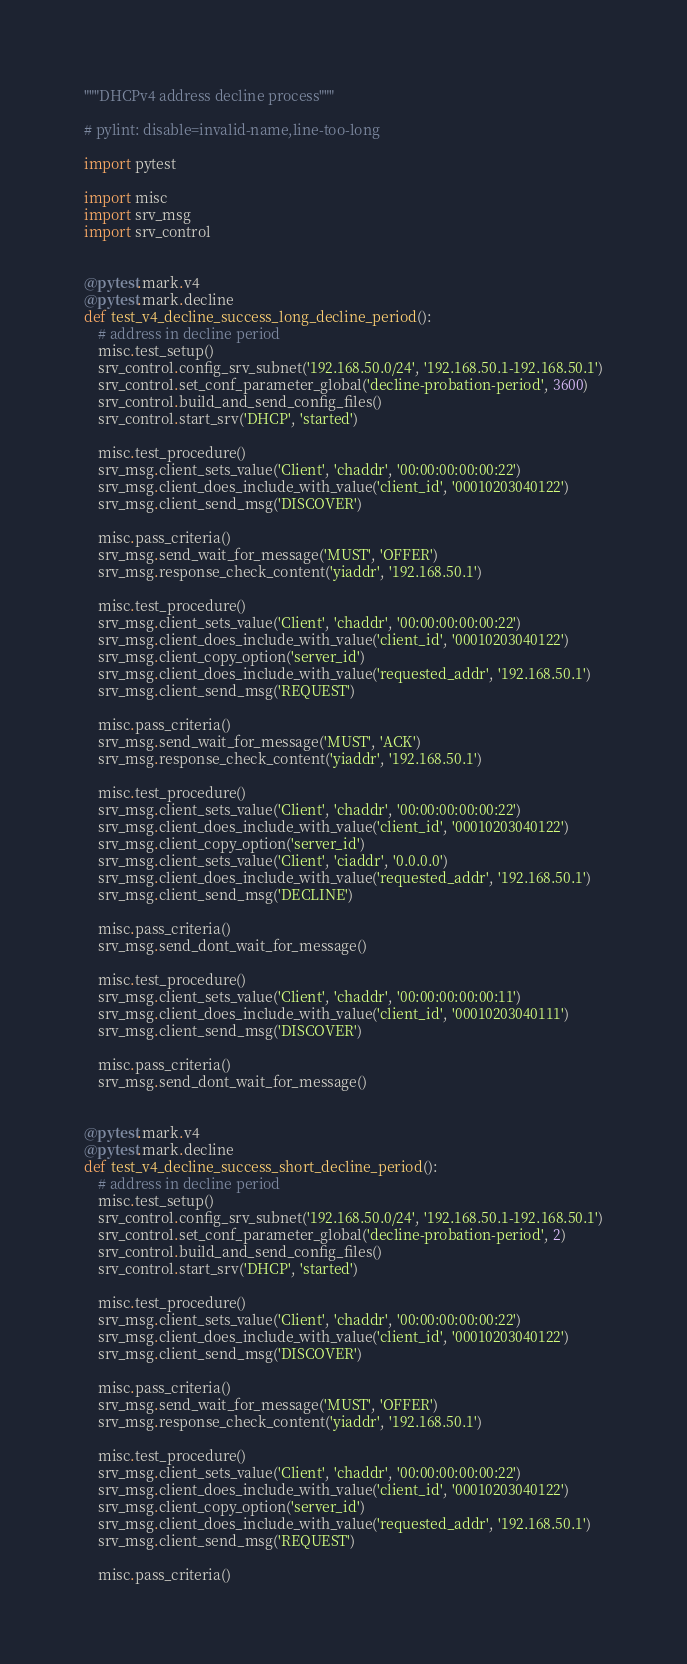Convert code to text. <code><loc_0><loc_0><loc_500><loc_500><_Python_>"""DHCPv4 address decline process"""

# pylint: disable=invalid-name,line-too-long

import pytest

import misc
import srv_msg
import srv_control


@pytest.mark.v4
@pytest.mark.decline
def test_v4_decline_success_long_decline_period():
    # address in decline period
    misc.test_setup()
    srv_control.config_srv_subnet('192.168.50.0/24', '192.168.50.1-192.168.50.1')
    srv_control.set_conf_parameter_global('decline-probation-period', 3600)
    srv_control.build_and_send_config_files()
    srv_control.start_srv('DHCP', 'started')

    misc.test_procedure()
    srv_msg.client_sets_value('Client', 'chaddr', '00:00:00:00:00:22')
    srv_msg.client_does_include_with_value('client_id', '00010203040122')
    srv_msg.client_send_msg('DISCOVER')

    misc.pass_criteria()
    srv_msg.send_wait_for_message('MUST', 'OFFER')
    srv_msg.response_check_content('yiaddr', '192.168.50.1')

    misc.test_procedure()
    srv_msg.client_sets_value('Client', 'chaddr', '00:00:00:00:00:22')
    srv_msg.client_does_include_with_value('client_id', '00010203040122')
    srv_msg.client_copy_option('server_id')
    srv_msg.client_does_include_with_value('requested_addr', '192.168.50.1')
    srv_msg.client_send_msg('REQUEST')

    misc.pass_criteria()
    srv_msg.send_wait_for_message('MUST', 'ACK')
    srv_msg.response_check_content('yiaddr', '192.168.50.1')

    misc.test_procedure()
    srv_msg.client_sets_value('Client', 'chaddr', '00:00:00:00:00:22')
    srv_msg.client_does_include_with_value('client_id', '00010203040122')
    srv_msg.client_copy_option('server_id')
    srv_msg.client_sets_value('Client', 'ciaddr', '0.0.0.0')
    srv_msg.client_does_include_with_value('requested_addr', '192.168.50.1')
    srv_msg.client_send_msg('DECLINE')

    misc.pass_criteria()
    srv_msg.send_dont_wait_for_message()

    misc.test_procedure()
    srv_msg.client_sets_value('Client', 'chaddr', '00:00:00:00:00:11')
    srv_msg.client_does_include_with_value('client_id', '00010203040111')
    srv_msg.client_send_msg('DISCOVER')

    misc.pass_criteria()
    srv_msg.send_dont_wait_for_message()


@pytest.mark.v4
@pytest.mark.decline
def test_v4_decline_success_short_decline_period():
    # address in decline period
    misc.test_setup()
    srv_control.config_srv_subnet('192.168.50.0/24', '192.168.50.1-192.168.50.1')
    srv_control.set_conf_parameter_global('decline-probation-period', 2)
    srv_control.build_and_send_config_files()
    srv_control.start_srv('DHCP', 'started')

    misc.test_procedure()
    srv_msg.client_sets_value('Client', 'chaddr', '00:00:00:00:00:22')
    srv_msg.client_does_include_with_value('client_id', '00010203040122')
    srv_msg.client_send_msg('DISCOVER')

    misc.pass_criteria()
    srv_msg.send_wait_for_message('MUST', 'OFFER')
    srv_msg.response_check_content('yiaddr', '192.168.50.1')

    misc.test_procedure()
    srv_msg.client_sets_value('Client', 'chaddr', '00:00:00:00:00:22')
    srv_msg.client_does_include_with_value('client_id', '00010203040122')
    srv_msg.client_copy_option('server_id')
    srv_msg.client_does_include_with_value('requested_addr', '192.168.50.1')
    srv_msg.client_send_msg('REQUEST')

    misc.pass_criteria()</code> 